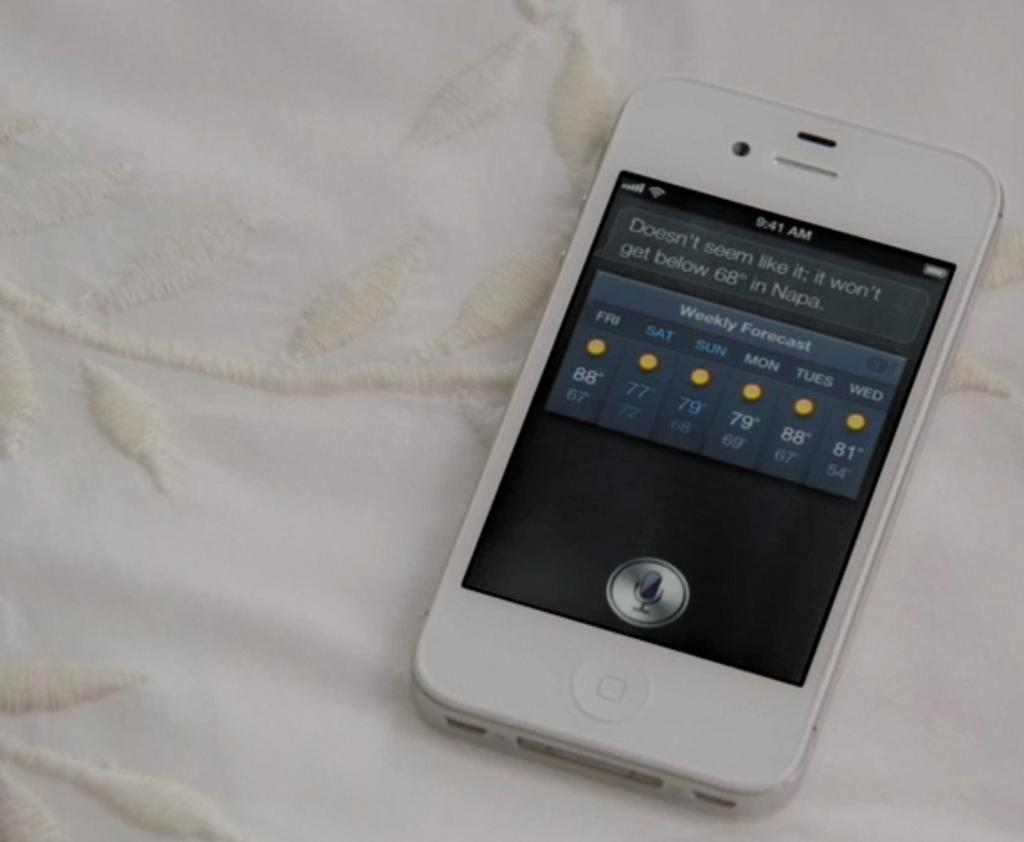Provide a one-sentence caption for the provided image. A cell phone with a weather forecast saying 'weekly forecast'. 